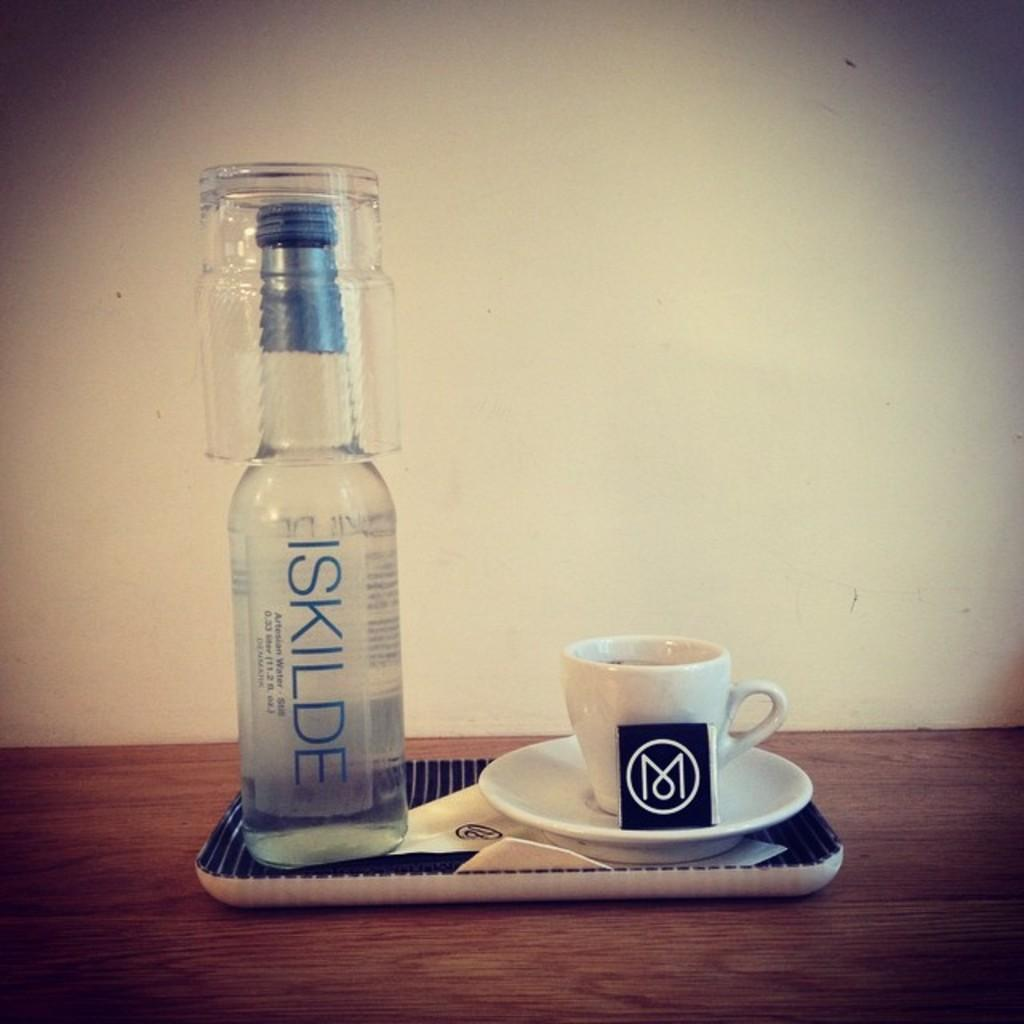<image>
Give a short and clear explanation of the subsequent image. A bottle of ISKILDE water sits next to a tea cup on a tray. 